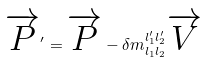Convert formula to latex. <formula><loc_0><loc_0><loc_500><loc_500>\overrightarrow { P } ^ { \prime } = \overrightarrow { P } - \delta m _ { l _ { 1 } l _ { 2 } } ^ { l _ { 1 } ^ { \prime } l _ { 2 } ^ { \prime } } \overrightarrow { V }</formula> 